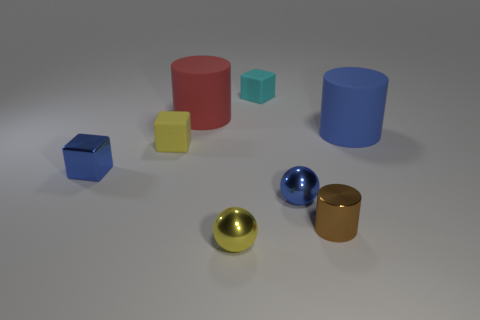What is the shape of the metal object that is the same color as the metallic cube?
Provide a succinct answer. Sphere. What size is the matte object that is the same color as the metallic block?
Your answer should be very brief. Large. What number of yellow metal things have the same size as the cyan object?
Your answer should be compact. 1. Is the size of the blue metallic cube to the left of the large blue cylinder the same as the thing behind the red rubber cylinder?
Make the answer very short. Yes. There is a rubber object that is both right of the yellow rubber object and left of the small yellow shiny ball; what is its shape?
Provide a short and direct response. Cylinder. Are there any other blocks that have the same color as the metallic block?
Offer a very short reply. No. Are there any blue shiny balls?
Offer a very short reply. Yes. What color is the cylinder that is in front of the small metal block?
Offer a terse response. Brown. There is a cyan object; is it the same size as the sphere left of the cyan cube?
Your response must be concise. Yes. There is a cylinder that is right of the yellow metallic sphere and behind the tiny brown metal thing; what size is it?
Provide a succinct answer. Large. 